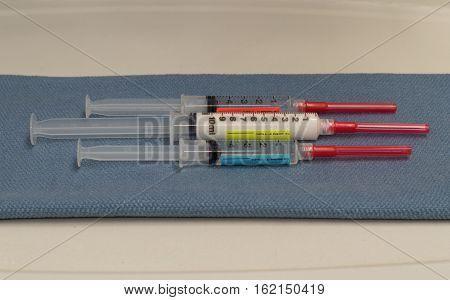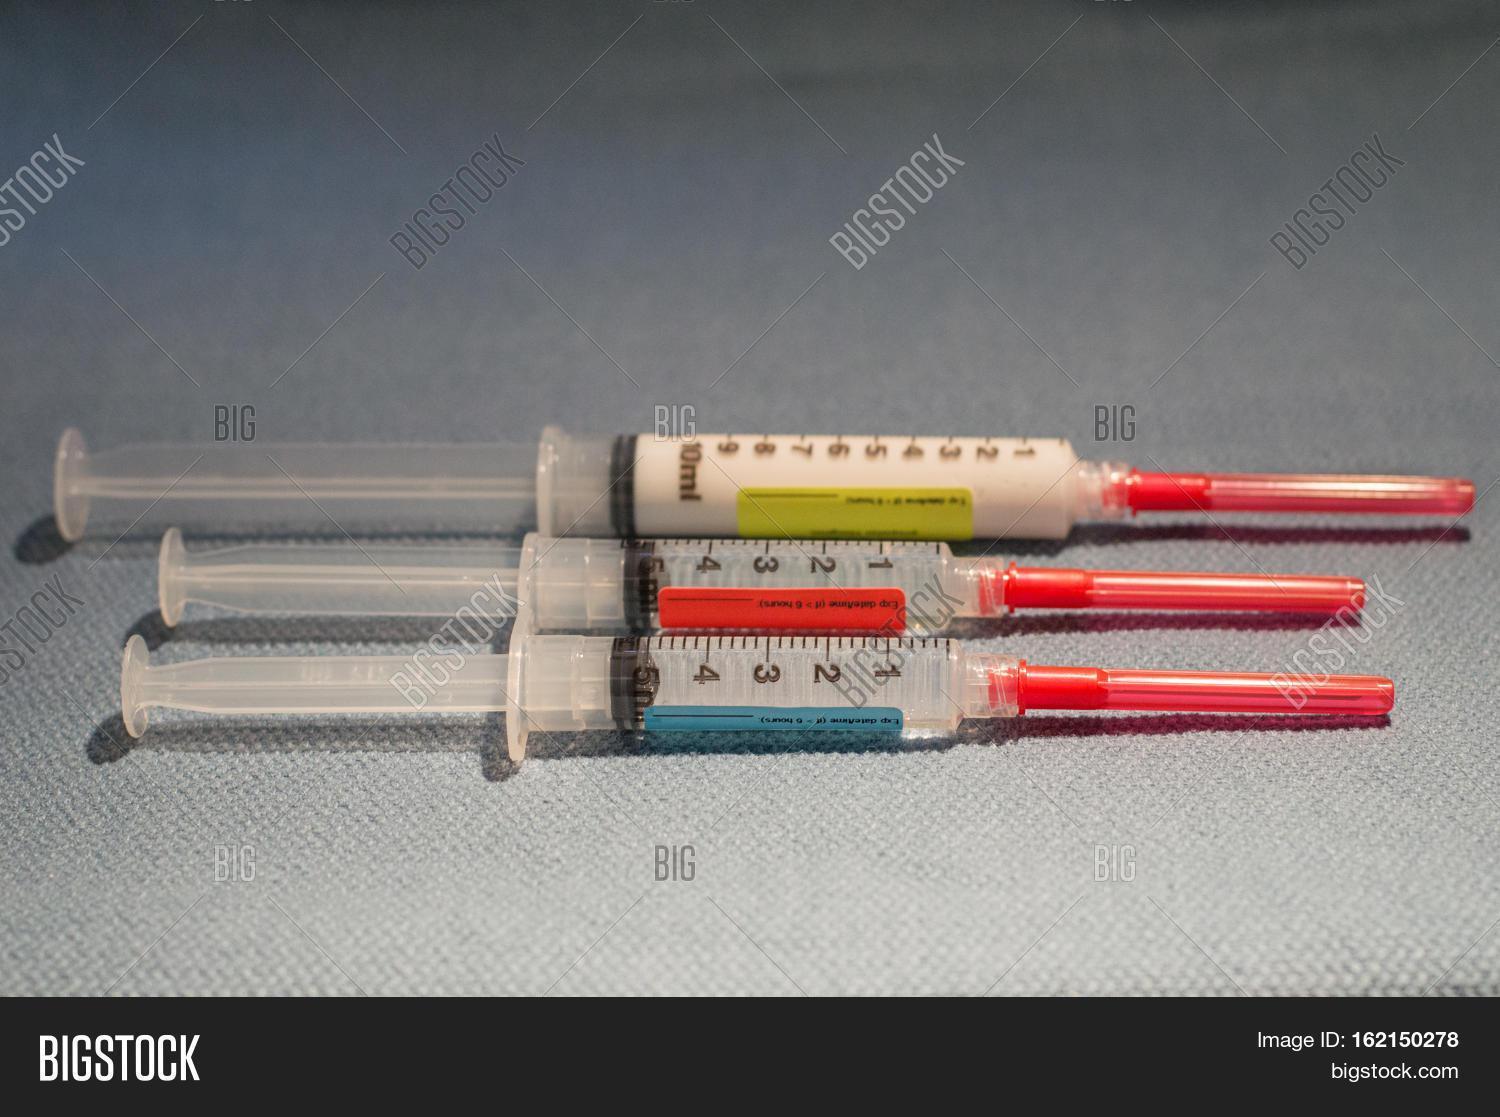The first image is the image on the left, the second image is the image on the right. Analyze the images presented: Is the assertion "An image shows exactly two syringe-related items displayed horizontally." valid? Answer yes or no. No. The first image is the image on the left, the second image is the image on the right. Evaluate the accuracy of this statement regarding the images: "At least one of the images has exactly three syringes.". Is it true? Answer yes or no. Yes. 